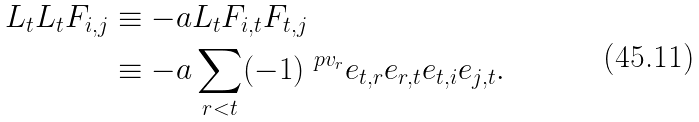<formula> <loc_0><loc_0><loc_500><loc_500>L _ { t } L _ { t } F _ { i , j } & \equiv - a L _ { t } F _ { i , t } F _ { t , j } \\ & \equiv - a \sum _ { r < t } ( - 1 ) ^ { \ p { v } _ { r } } e _ { t , r } e _ { r , t } e _ { t , i } e _ { j , t } .</formula> 